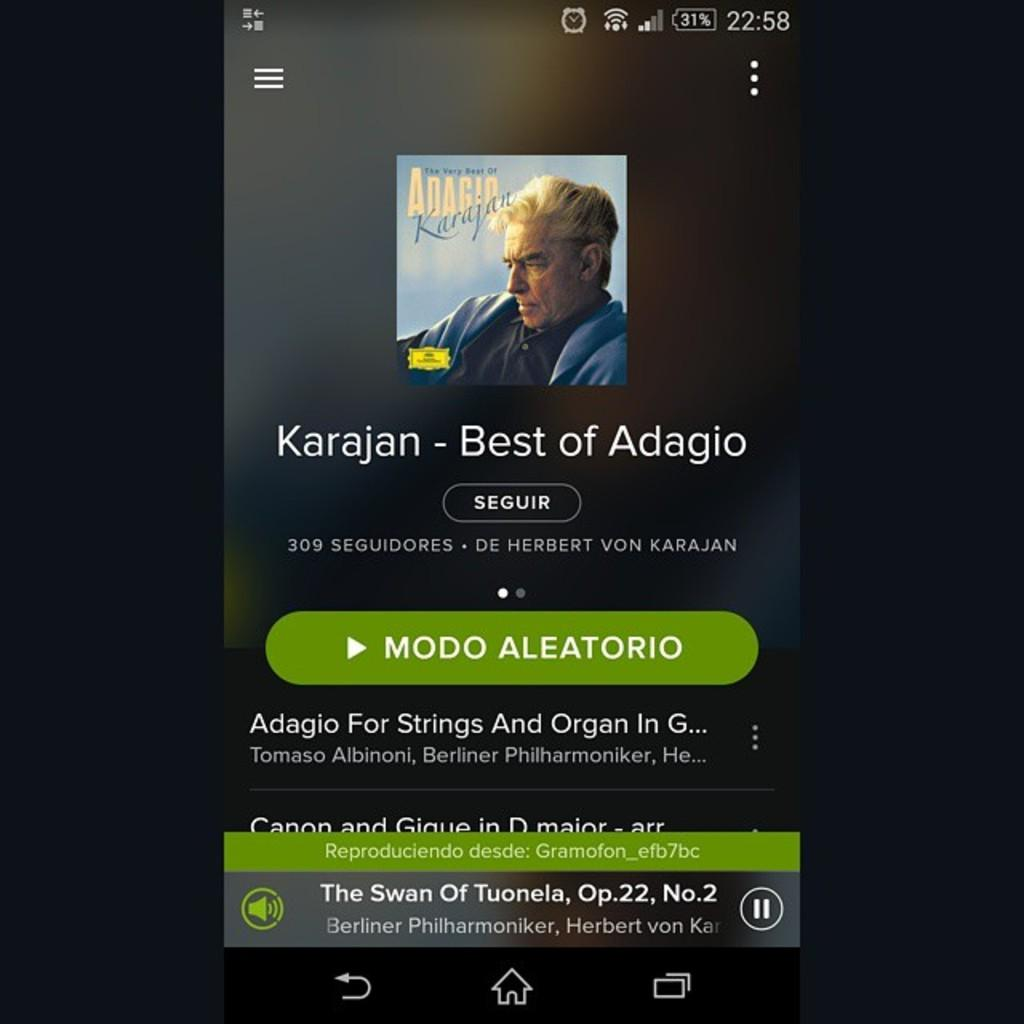<image>
Render a clear and concise summary of the photo. a page of an artist that says Best of Adagio 